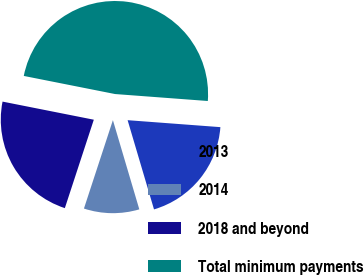Convert chart to OTSL. <chart><loc_0><loc_0><loc_500><loc_500><pie_chart><fcel>2013<fcel>2014<fcel>2018 and beyond<fcel>Total minimum payments<nl><fcel>19.23%<fcel>9.62%<fcel>23.08%<fcel>48.08%<nl></chart> 